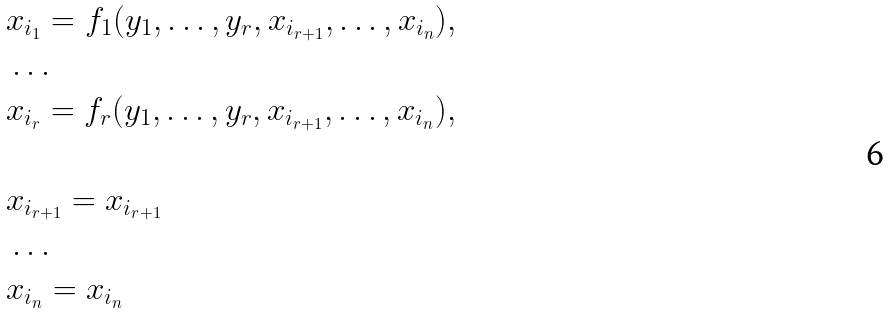Convert formula to latex. <formula><loc_0><loc_0><loc_500><loc_500>& x _ { i _ { 1 } } = f _ { 1 } ( y _ { 1 } , \dots , y _ { r } , x _ { i _ { r + 1 } } , \dots , x _ { i _ { n } } ) , \\ & \dots \\ & x _ { i _ { r } } = f _ { r } ( y _ { 1 } , \dots , y _ { r } , x _ { i _ { r + 1 } } , \dots , x _ { i _ { n } } ) , \\ \\ & x _ { i _ { r + 1 } } = x _ { i _ { r + 1 } } \\ & \dots \\ & x _ { i _ { n } } = x _ { i _ { n } }</formula> 